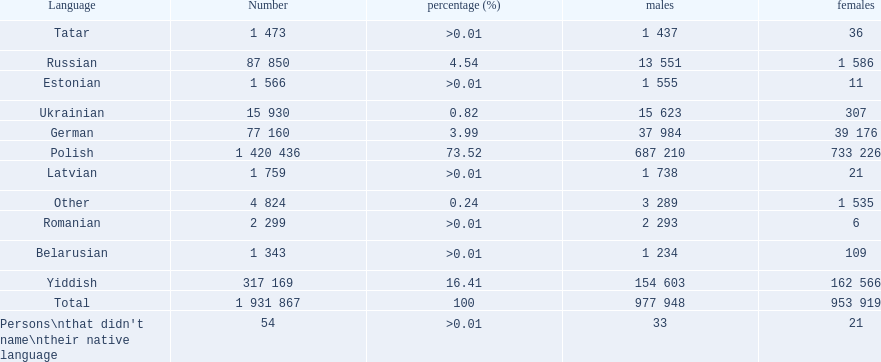What are all the languages? Polish, Yiddish, Russian, German, Ukrainian, Romanian, Latvian, Estonian, Tatar, Belarusian, Other. Which only have percentages >0.01? Romanian, Latvian, Estonian, Tatar, Belarusian. Of these, which has the greatest number of speakers? Romanian. 